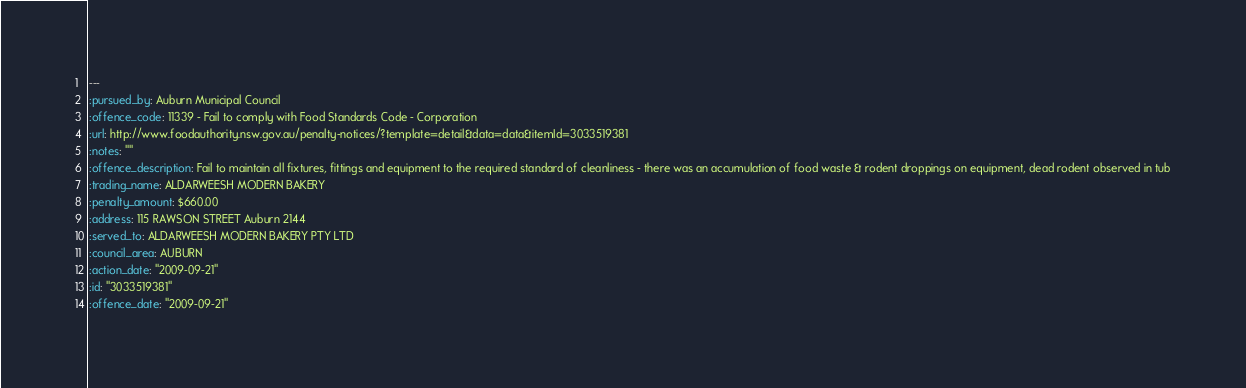<code> <loc_0><loc_0><loc_500><loc_500><_YAML_>--- 
:pursued_by: Auburn Municipal Council
:offence_code: 11339 - Fail to comply with Food Standards Code - Corporation
:url: http://www.foodauthority.nsw.gov.au/penalty-notices/?template=detail&data=data&itemId=3033519381
:notes: ""
:offence_description: Fail to maintain all fixtures, fittings and equipment to the required standard of cleanliness - there was an accumulation of food waste & rodent droppings on equipment, dead rodent observed in tub
:trading_name: ALDARWEESH MODERN BAKERY
:penalty_amount: $660.00
:address: 115 RAWSON STREET Auburn 2144
:served_to: ALDARWEESH MODERN BAKERY PTY LTD
:council_area: AUBURN
:action_date: "2009-09-21"
:id: "3033519381"
:offence_date: "2009-09-21"
</code> 